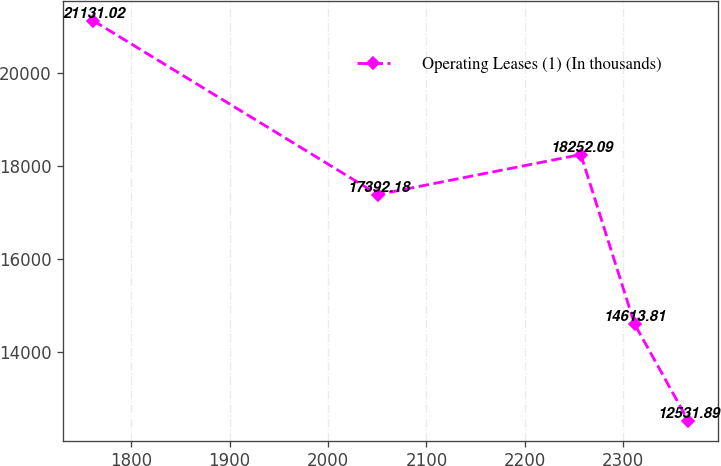<chart> <loc_0><loc_0><loc_500><loc_500><line_chart><ecel><fcel>Operating Leases (1) (In thousands)<nl><fcel>1761.35<fcel>21131<nl><fcel>2050.73<fcel>17392.2<nl><fcel>2256.78<fcel>18252.1<nl><fcel>2311.35<fcel>14613.8<nl><fcel>2365.92<fcel>12531.9<nl></chart> 